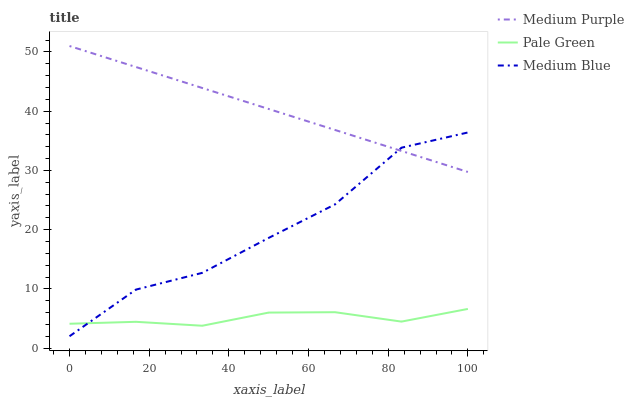Does Pale Green have the minimum area under the curve?
Answer yes or no. Yes. Does Medium Purple have the maximum area under the curve?
Answer yes or no. Yes. Does Medium Blue have the minimum area under the curve?
Answer yes or no. No. Does Medium Blue have the maximum area under the curve?
Answer yes or no. No. Is Medium Purple the smoothest?
Answer yes or no. Yes. Is Medium Blue the roughest?
Answer yes or no. Yes. Is Pale Green the smoothest?
Answer yes or no. No. Is Pale Green the roughest?
Answer yes or no. No. Does Medium Blue have the lowest value?
Answer yes or no. Yes. Does Pale Green have the lowest value?
Answer yes or no. No. Does Medium Purple have the highest value?
Answer yes or no. Yes. Does Medium Blue have the highest value?
Answer yes or no. No. Is Pale Green less than Medium Purple?
Answer yes or no. Yes. Is Medium Purple greater than Pale Green?
Answer yes or no. Yes. Does Medium Blue intersect Pale Green?
Answer yes or no. Yes. Is Medium Blue less than Pale Green?
Answer yes or no. No. Is Medium Blue greater than Pale Green?
Answer yes or no. No. Does Pale Green intersect Medium Purple?
Answer yes or no. No. 